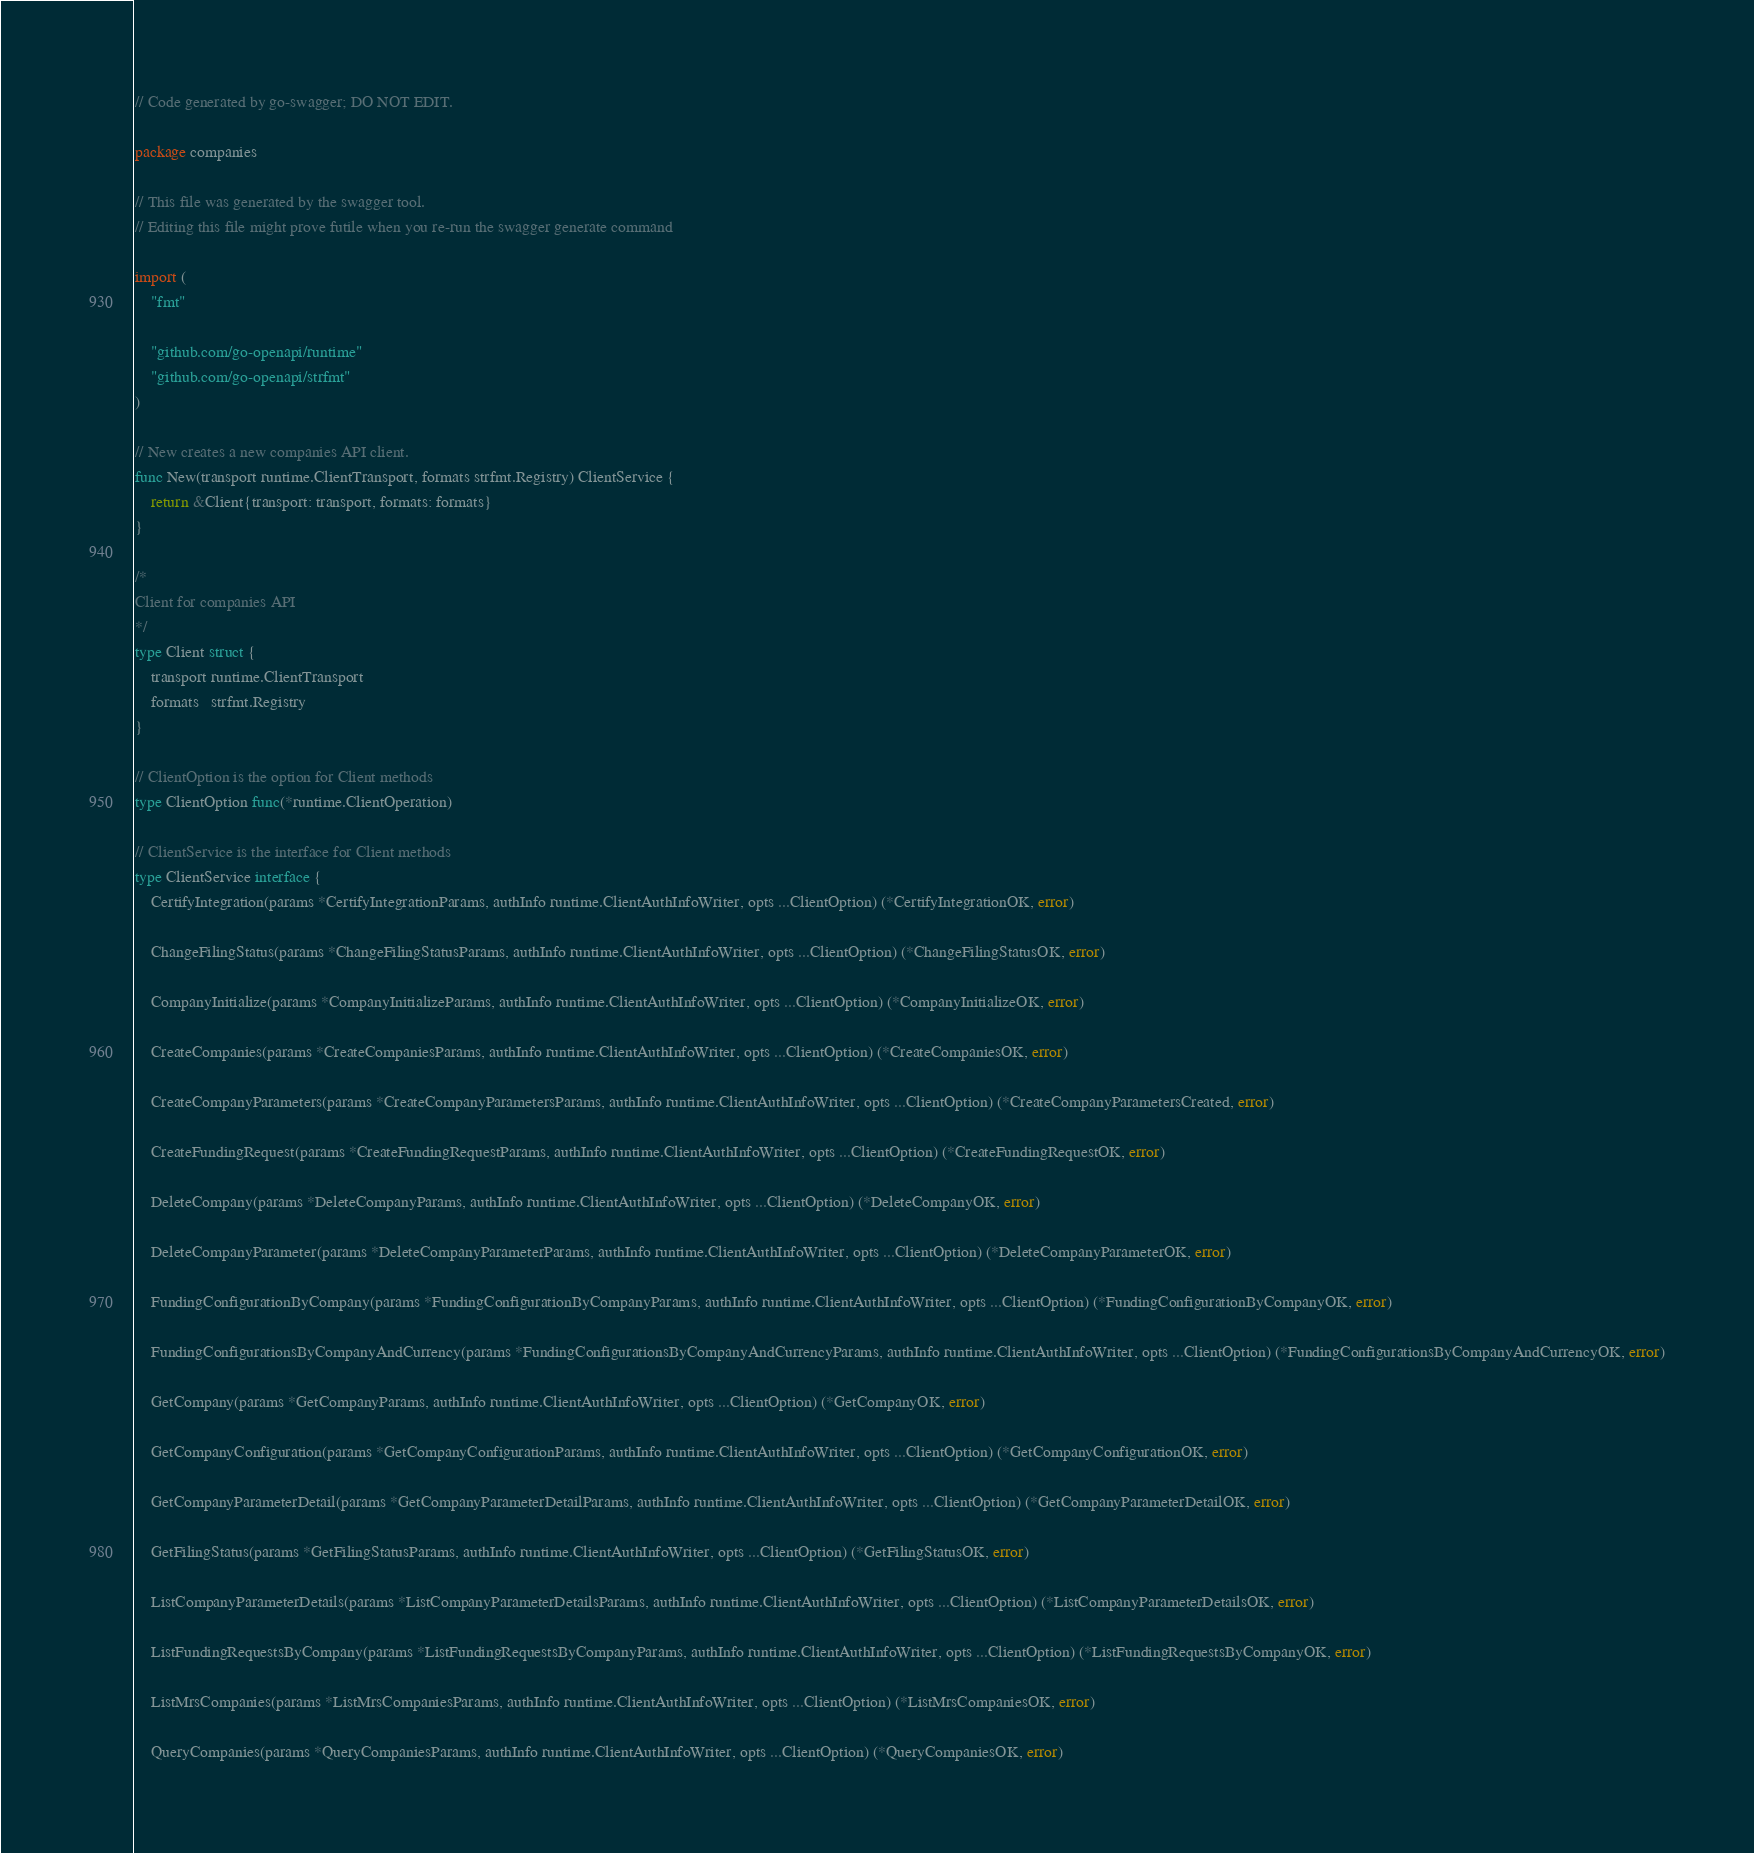Convert code to text. <code><loc_0><loc_0><loc_500><loc_500><_Go_>// Code generated by go-swagger; DO NOT EDIT.

package companies

// This file was generated by the swagger tool.
// Editing this file might prove futile when you re-run the swagger generate command

import (
	"fmt"

	"github.com/go-openapi/runtime"
	"github.com/go-openapi/strfmt"
)

// New creates a new companies API client.
func New(transport runtime.ClientTransport, formats strfmt.Registry) ClientService {
	return &Client{transport: transport, formats: formats}
}

/*
Client for companies API
*/
type Client struct {
	transport runtime.ClientTransport
	formats   strfmt.Registry
}

// ClientOption is the option for Client methods
type ClientOption func(*runtime.ClientOperation)

// ClientService is the interface for Client methods
type ClientService interface {
	CertifyIntegration(params *CertifyIntegrationParams, authInfo runtime.ClientAuthInfoWriter, opts ...ClientOption) (*CertifyIntegrationOK, error)

	ChangeFilingStatus(params *ChangeFilingStatusParams, authInfo runtime.ClientAuthInfoWriter, opts ...ClientOption) (*ChangeFilingStatusOK, error)

	CompanyInitialize(params *CompanyInitializeParams, authInfo runtime.ClientAuthInfoWriter, opts ...ClientOption) (*CompanyInitializeOK, error)

	CreateCompanies(params *CreateCompaniesParams, authInfo runtime.ClientAuthInfoWriter, opts ...ClientOption) (*CreateCompaniesOK, error)

	CreateCompanyParameters(params *CreateCompanyParametersParams, authInfo runtime.ClientAuthInfoWriter, opts ...ClientOption) (*CreateCompanyParametersCreated, error)

	CreateFundingRequest(params *CreateFundingRequestParams, authInfo runtime.ClientAuthInfoWriter, opts ...ClientOption) (*CreateFundingRequestOK, error)

	DeleteCompany(params *DeleteCompanyParams, authInfo runtime.ClientAuthInfoWriter, opts ...ClientOption) (*DeleteCompanyOK, error)

	DeleteCompanyParameter(params *DeleteCompanyParameterParams, authInfo runtime.ClientAuthInfoWriter, opts ...ClientOption) (*DeleteCompanyParameterOK, error)

	FundingConfigurationByCompany(params *FundingConfigurationByCompanyParams, authInfo runtime.ClientAuthInfoWriter, opts ...ClientOption) (*FundingConfigurationByCompanyOK, error)

	FundingConfigurationsByCompanyAndCurrency(params *FundingConfigurationsByCompanyAndCurrencyParams, authInfo runtime.ClientAuthInfoWriter, opts ...ClientOption) (*FundingConfigurationsByCompanyAndCurrencyOK, error)

	GetCompany(params *GetCompanyParams, authInfo runtime.ClientAuthInfoWriter, opts ...ClientOption) (*GetCompanyOK, error)

	GetCompanyConfiguration(params *GetCompanyConfigurationParams, authInfo runtime.ClientAuthInfoWriter, opts ...ClientOption) (*GetCompanyConfigurationOK, error)

	GetCompanyParameterDetail(params *GetCompanyParameterDetailParams, authInfo runtime.ClientAuthInfoWriter, opts ...ClientOption) (*GetCompanyParameterDetailOK, error)

	GetFilingStatus(params *GetFilingStatusParams, authInfo runtime.ClientAuthInfoWriter, opts ...ClientOption) (*GetFilingStatusOK, error)

	ListCompanyParameterDetails(params *ListCompanyParameterDetailsParams, authInfo runtime.ClientAuthInfoWriter, opts ...ClientOption) (*ListCompanyParameterDetailsOK, error)

	ListFundingRequestsByCompany(params *ListFundingRequestsByCompanyParams, authInfo runtime.ClientAuthInfoWriter, opts ...ClientOption) (*ListFundingRequestsByCompanyOK, error)

	ListMrsCompanies(params *ListMrsCompaniesParams, authInfo runtime.ClientAuthInfoWriter, opts ...ClientOption) (*ListMrsCompaniesOK, error)

	QueryCompanies(params *QueryCompaniesParams, authInfo runtime.ClientAuthInfoWriter, opts ...ClientOption) (*QueryCompaniesOK, error)
</code> 